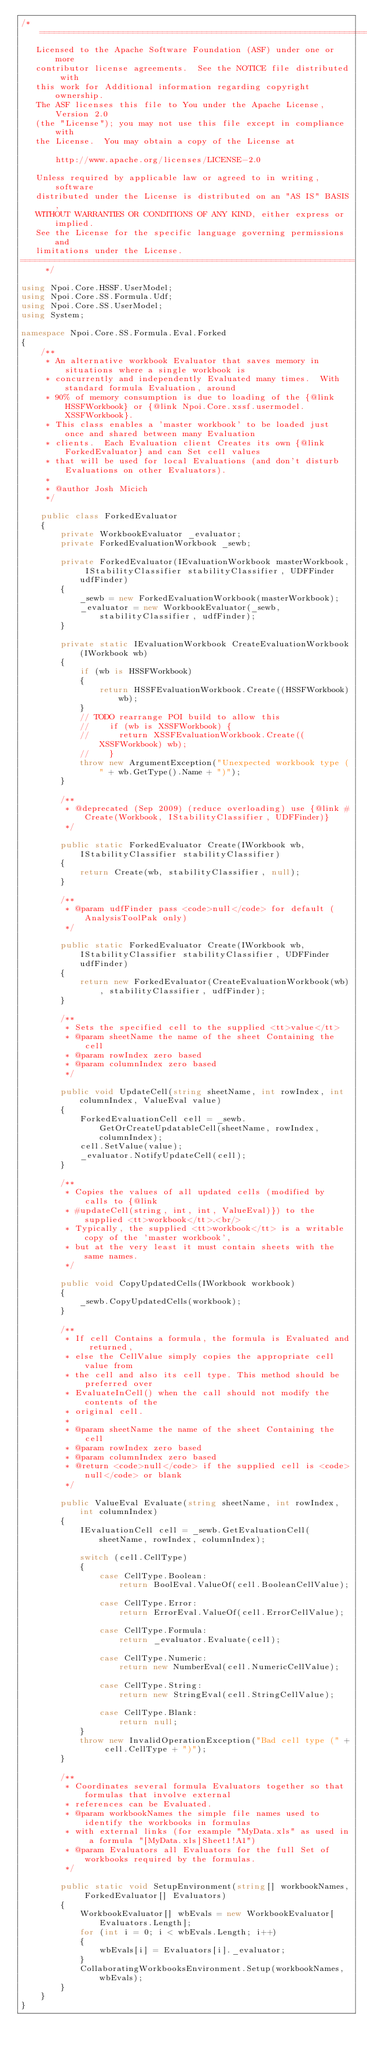<code> <loc_0><loc_0><loc_500><loc_500><_C#_>/* ====================================================================
   Licensed to the Apache Software Foundation (ASF) under one or more
   contributor license agreements.  See the NOTICE file distributed with
   this work for Additional information regarding copyright ownership.
   The ASF licenses this file to You under the Apache License, Version 2.0
   (the "License"); you may not use this file except in compliance with
   the License.  You may obtain a copy of the License at

       http://www.apache.org/licenses/LICENSE-2.0

   Unless required by applicable law or agreed to in writing, software
   distributed under the License is distributed on an "AS IS" BASIS,
   WITHOUT WARRANTIES OR CONDITIONS OF ANY KIND, either express or implied.
   See the License for the specific language governing permissions and
   limitations under the License.
==================================================================== */

using Npoi.Core.HSSF.UserModel;
using Npoi.Core.SS.Formula.Udf;
using Npoi.Core.SS.UserModel;
using System;

namespace Npoi.Core.SS.Formula.Eval.Forked
{
    /**
     * An alternative workbook Evaluator that saves memory in situations where a single workbook is
     * concurrently and independently Evaluated many times.  With standard formula Evaluation, around
     * 90% of memory consumption is due to loading of the {@link HSSFWorkbook} or {@link Npoi.Core.xssf.usermodel.XSSFWorkbook}.
     * This class enables a 'master workbook' to be loaded just once and shared between many Evaluation
     * clients.  Each Evaluation client Creates its own {@link ForkedEvaluator} and can Set cell values
     * that will be used for local Evaluations (and don't disturb Evaluations on other Evaluators).
     *
     * @author Josh Micich
     */

    public class ForkedEvaluator
    {
        private WorkbookEvaluator _evaluator;
        private ForkedEvaluationWorkbook _sewb;

        private ForkedEvaluator(IEvaluationWorkbook masterWorkbook, IStabilityClassifier stabilityClassifier, UDFFinder udfFinder)
        {
            _sewb = new ForkedEvaluationWorkbook(masterWorkbook);
            _evaluator = new WorkbookEvaluator(_sewb, stabilityClassifier, udfFinder);
        }

        private static IEvaluationWorkbook CreateEvaluationWorkbook(IWorkbook wb)
        {
            if (wb is HSSFWorkbook)
            {
                return HSSFEvaluationWorkbook.Create((HSSFWorkbook)wb);
            }
            // TODO rearrange POI build to allow this
            //		if (wb is XSSFWorkbook) {
            //			return XSSFEvaluationWorkbook.Create((XSSFWorkbook) wb);
            //		}
            throw new ArgumentException("Unexpected workbook type (" + wb.GetType().Name + ")");
        }

        /**
         * @deprecated (Sep 2009) (reduce overloading) use {@link #Create(Workbook, IStabilityClassifier, UDFFinder)}
         */

        public static ForkedEvaluator Create(IWorkbook wb, IStabilityClassifier stabilityClassifier)
        {
            return Create(wb, stabilityClassifier, null);
        }

        /**
         * @param udfFinder pass <code>null</code> for default (AnalysisToolPak only)
         */

        public static ForkedEvaluator Create(IWorkbook wb, IStabilityClassifier stabilityClassifier, UDFFinder udfFinder)
        {
            return new ForkedEvaluator(CreateEvaluationWorkbook(wb), stabilityClassifier, udfFinder);
        }

        /**
         * Sets the specified cell to the supplied <tt>value</tt>
         * @param sheetName the name of the sheet Containing the cell
         * @param rowIndex zero based
         * @param columnIndex zero based
         */

        public void UpdateCell(string sheetName, int rowIndex, int columnIndex, ValueEval value)
        {
            ForkedEvaluationCell cell = _sewb.GetOrCreateUpdatableCell(sheetName, rowIndex, columnIndex);
            cell.SetValue(value);
            _evaluator.NotifyUpdateCell(cell);
        }

        /**
         * Copies the values of all updated cells (modified by calls to {@link
         * #updateCell(string, int, int, ValueEval)}) to the supplied <tt>workbook</tt>.<br/>
         * Typically, the supplied <tt>workbook</tt> is a writable copy of the 'master workbook',
         * but at the very least it must contain sheets with the same names.
         */

        public void CopyUpdatedCells(IWorkbook workbook)
        {
            _sewb.CopyUpdatedCells(workbook);
        }

        /**
         * If cell Contains a formula, the formula is Evaluated and returned,
         * else the CellValue simply copies the appropriate cell value from
         * the cell and also its cell type. This method should be preferred over
         * EvaluateInCell() when the call should not modify the contents of the
         * original cell.
         *
         * @param sheetName the name of the sheet Containing the cell
         * @param rowIndex zero based
         * @param columnIndex zero based
         * @return <code>null</code> if the supplied cell is <code>null</code> or blank
         */

        public ValueEval Evaluate(string sheetName, int rowIndex, int columnIndex)
        {
            IEvaluationCell cell = _sewb.GetEvaluationCell(sheetName, rowIndex, columnIndex);

            switch (cell.CellType)
            {
                case CellType.Boolean:
                    return BoolEval.ValueOf(cell.BooleanCellValue);

                case CellType.Error:
                    return ErrorEval.ValueOf(cell.ErrorCellValue);

                case CellType.Formula:
                    return _evaluator.Evaluate(cell);

                case CellType.Numeric:
                    return new NumberEval(cell.NumericCellValue);

                case CellType.String:
                    return new StringEval(cell.StringCellValue);

                case CellType.Blank:
                    return null;
            }
            throw new InvalidOperationException("Bad cell type (" + cell.CellType + ")");
        }

        /**
         * Coordinates several formula Evaluators together so that formulas that involve external
         * references can be Evaluated.
         * @param workbookNames the simple file names used to identify the workbooks in formulas
         * with external links (for example "MyData.xls" as used in a formula "[MyData.xls]Sheet1!A1")
         * @param Evaluators all Evaluators for the full Set of workbooks required by the formulas.
         */

        public static void SetupEnvironment(string[] workbookNames, ForkedEvaluator[] Evaluators)
        {
            WorkbookEvaluator[] wbEvals = new WorkbookEvaluator[Evaluators.Length];
            for (int i = 0; i < wbEvals.Length; i++)
            {
                wbEvals[i] = Evaluators[i]._evaluator;
            }
            CollaboratingWorkbooksEnvironment.Setup(workbookNames, wbEvals);
        }
    }
}</code> 